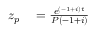<formula> <loc_0><loc_0><loc_500><loc_500>\begin{array} { r l r l } { z _ { p } } & = { \frac { e ^ { ( - 1 + i ) t } } { P ( - 1 + i ) } } } \end{array}</formula> 